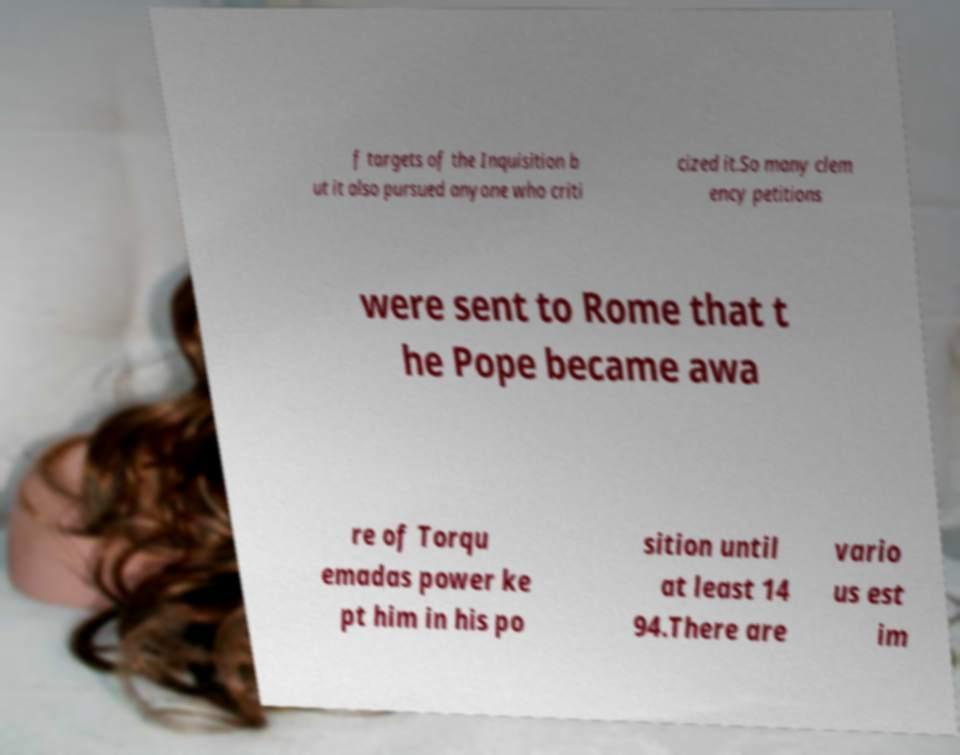For documentation purposes, I need the text within this image transcribed. Could you provide that? f targets of the Inquisition b ut it also pursued anyone who criti cized it.So many clem ency petitions were sent to Rome that t he Pope became awa re of Torqu emadas power ke pt him in his po sition until at least 14 94.There are vario us est im 